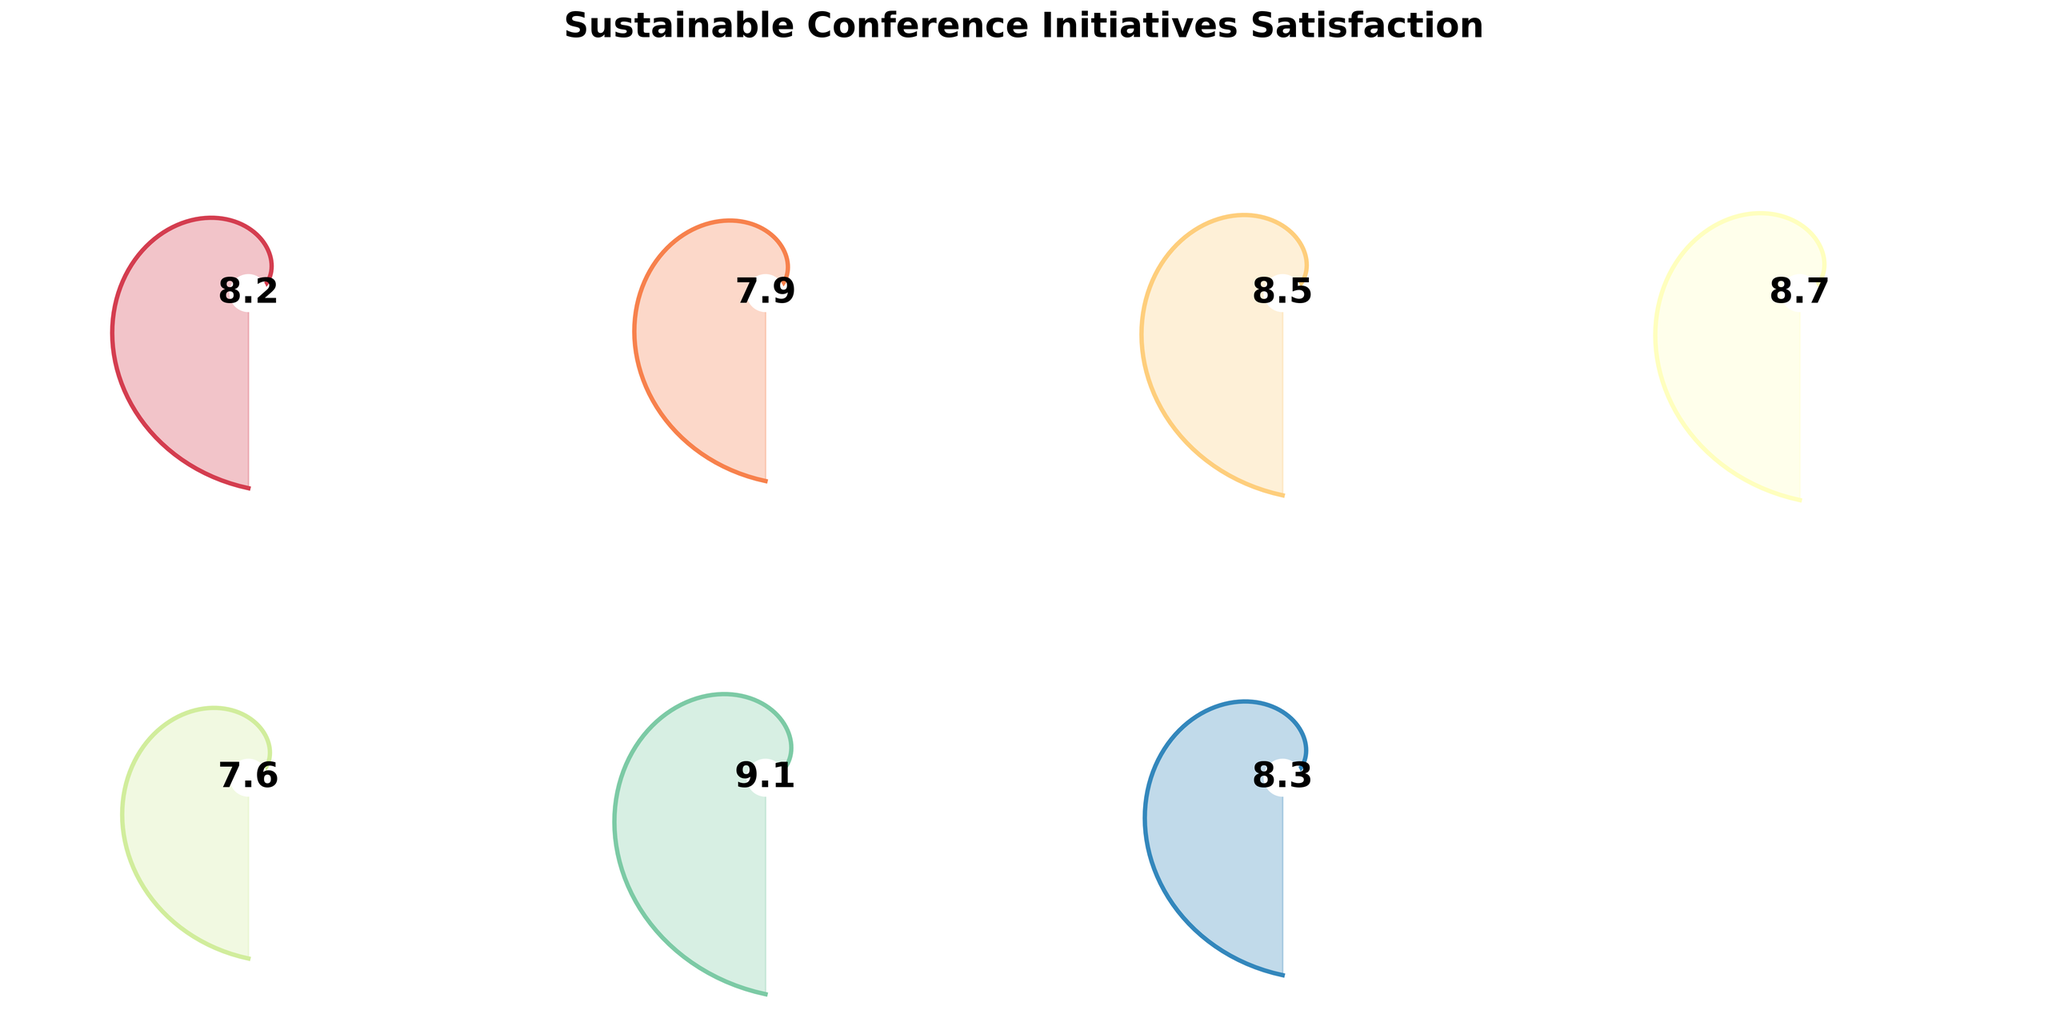What's the overall satisfaction score? Look at the gauge marked 'Overall Satisfaction' and observe the value displayed in the center.
Answer: 8.2 Which sustainable initiative scored the highest in attendee satisfaction? Compare all the values displayed in the center of each gauge and identify the highest.
Answer: Digital Over Print Materials Which initiative had the lowest satisfaction score? Review all the values displayed in the center of each gauge and identify the smallest.
Answer: Energy Efficiency Measures What is the average satisfaction score for all initiatives combined? Sum all the values (8.2 + 7.9 + 8.5 + 8.7 + 7.6 + 9.1 + 8.3) and divide by the total number of initiatives (7). The average calculation is (8.2 + 7.9 + 8.5 + 8.7 + 7.6 + 9.1 + 8.3) / 7 = 58.3 / 7
Answer: 8.33 How does attendee satisfaction for Green Transportation Options compare to Sustainable Catering? Note the values for both Green Transportation Options (8.5) and Sustainable Catering (8.7), and determine which is higher.
Answer: Sustainable Catering is higher What is the difference in satisfaction scores between Waste Reduction Initiatives and Carbon Offset Program? Subtract the value of Waste Reduction Initiatives (7.9) from Carbon Offset Program (8.3). The difference calculation is 8.3 - 7.9.
Answer: 0.4 Which initiative has a satisfaction score close to the overall satisfaction? Identify the value of the 'Overall Satisfaction' (8.2) and find the initiative with a value closest to it.
Answer: Carbon Offset Program Are Waste Reduction Initiatives and Energy Efficiency Measures' satisfaction scores above or below the overall average satisfaction score? Calculate the overall average satisfaction score (8.33) and compare it to the values for Waste Reduction Initiatives (7.9) and Energy Efficiency Measures (7.6). Both 7.9 and 7.6 are below the average.
Answer: Both are below How many initiatives have a satisfaction score of 8.5 or higher? Count the initiatives with values 8.5, 8.7, 9.1, and 8.3. These initiatives are Green Transportation Options, Sustainable Catering, Digital Over Print Materials, and Carbon Offset Program. There are 4 initiatives.
Answer: 4 What initiative has the satisfaction score closest to 9? Compare the initiatives’ scores and find the one most proximate to 9. The value 9.1 for Digital Over Print Materials is closest.
Answer: Digital Over Print Materials 